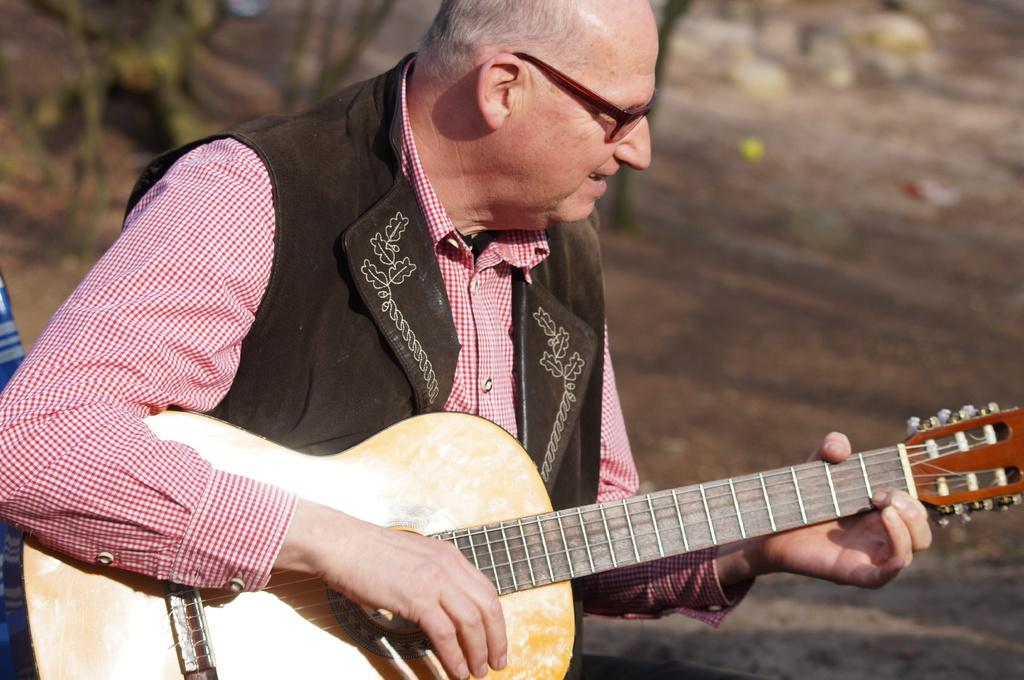What is the man in the image doing? The man is playing a guitar in the image. What type of clothing is the man wearing on his upper body? The man is wearing a red color checks shirt. What color is the coat the man is wearing? The man is wearing a brown color coat. What accessory is the man wearing on his face? The man is wearing specs. Can you see any roses growing near the man in the image? There are no roses visible in the image. Is there a church in the background of the image? There is no church present in the image. 